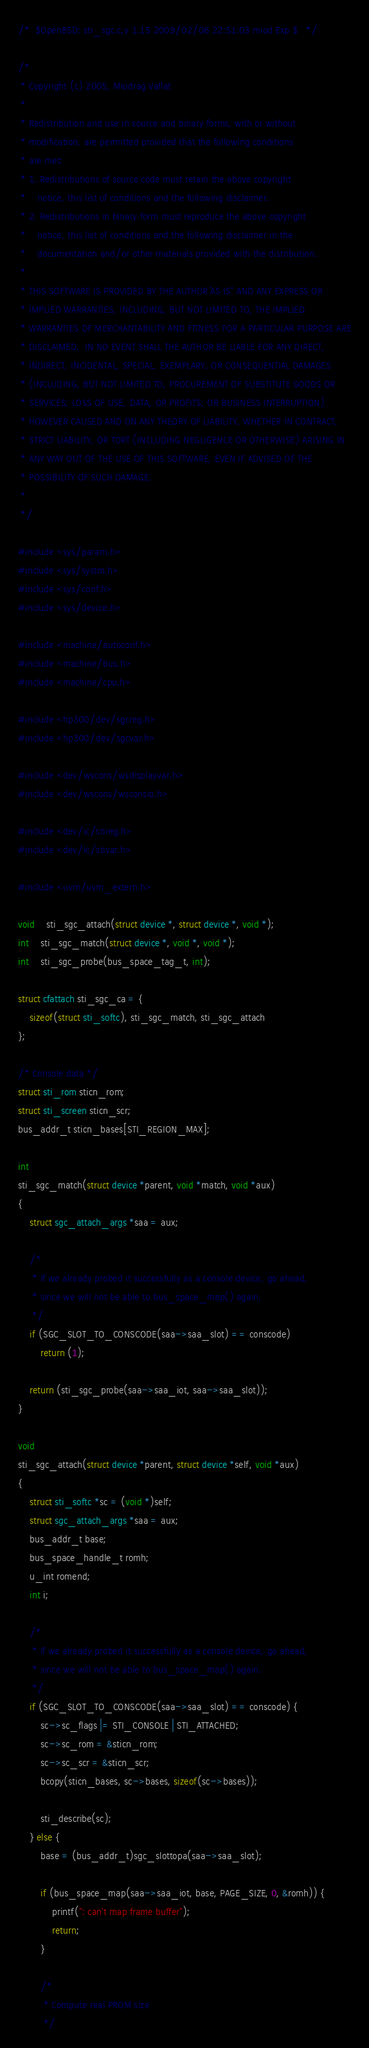<code> <loc_0><loc_0><loc_500><loc_500><_C_>/*	$OpenBSD: sti_sgc.c,v 1.15 2009/02/06 22:51:03 miod Exp $	*/

/*
 * Copyright (c) 2005, Miodrag Vallat
 *
 * Redistribution and use in source and binary forms, with or without
 * modification, are permitted provided that the following conditions
 * are met:
 * 1. Redistributions of source code must retain the above copyright
 *    notice, this list of conditions and the following disclaimer.
 * 2. Redistributions in binary form must reproduce the above copyright
 *    notice, this list of conditions and the following disclaimer in the
 *    documentation and/or other materials provided with the distribution.
 *
 * THIS SOFTWARE IS PROVIDED BY THE AUTHOR ``AS IS'' AND ANY EXPRESS OR
 * IMPLIED WARRANTIES, INCLUDING, BUT NOT LIMITED TO, THE IMPLIED
 * WARRANTIES OF MERCHANTABILITY AND FITNESS FOR A PARTICULAR PURPOSE ARE
 * DISCLAIMED.  IN NO EVENT SHALL THE AUTHOR BE LIABLE FOR ANY DIRECT,
 * INDIRECT, INCIDENTAL, SPECIAL, EXEMPLARY, OR CONSEQUENTIAL DAMAGES
 * (INCLUDING, BUT NOT LIMITED TO, PROCUREMENT OF SUBSTITUTE GOODS OR
 * SERVICES; LOSS OF USE, DATA, OR PROFITS; OR BUSINESS INTERRUPTION)
 * HOWEVER CAUSED AND ON ANY THEORY OF LIABILITY, WHETHER IN CONTRACT,
 * STRICT LIABILITY, OR TORT (INCLUDING NEGLIGENCE OR OTHERWISE) ARISING IN
 * ANY WAY OUT OF THE USE OF THIS SOFTWARE, EVEN IF ADVISED OF THE
 * POSSIBILITY OF SUCH DAMAGE.
 *
 */

#include <sys/param.h>
#include <sys/systm.h>
#include <sys/conf.h>
#include <sys/device.h>

#include <machine/autoconf.h>
#include <machine/bus.h>
#include <machine/cpu.h>

#include <hp300/dev/sgcreg.h>
#include <hp300/dev/sgcvar.h>

#include <dev/wscons/wsdisplayvar.h>
#include <dev/wscons/wsconsio.h>

#include <dev/ic/stireg.h>
#include <dev/ic/stivar.h>

#include <uvm/uvm_extern.h>

void	sti_sgc_attach(struct device *, struct device *, void *);
int	sti_sgc_match(struct device *, void *, void *);
int	sti_sgc_probe(bus_space_tag_t, int);

struct cfattach sti_sgc_ca = {
	sizeof(struct sti_softc), sti_sgc_match, sti_sgc_attach
};

/* Console data */
struct sti_rom sticn_rom;
struct sti_screen sticn_scr;
bus_addr_t sticn_bases[STI_REGION_MAX];

int
sti_sgc_match(struct device *parent, void *match, void *aux)
{
	struct sgc_attach_args *saa = aux;

	/*
	 * If we already probed it successfully as a console device, go ahead,
	 * since we will not be able to bus_space_map() again.
	 */
	if (SGC_SLOT_TO_CONSCODE(saa->saa_slot) == conscode)
		return (1);

	return (sti_sgc_probe(saa->saa_iot, saa->saa_slot));
}

void
sti_sgc_attach(struct device *parent, struct device *self, void *aux)
{
	struct sti_softc *sc = (void *)self;
	struct sgc_attach_args *saa = aux;
	bus_addr_t base;
	bus_space_handle_t romh;
	u_int romend;
	int i;

	/*
	 * If we already probed it successfully as a console device, go ahead,
	 * since we will not be able to bus_space_map() again.
	 */
	if (SGC_SLOT_TO_CONSCODE(saa->saa_slot) == conscode) {
		sc->sc_flags |= STI_CONSOLE | STI_ATTACHED;
		sc->sc_rom = &sticn_rom;
		sc->sc_scr = &sticn_scr;
		bcopy(sticn_bases, sc->bases, sizeof(sc->bases));

		sti_describe(sc);
	} else {
		base = (bus_addr_t)sgc_slottopa(saa->saa_slot);

		if (bus_space_map(saa->saa_iot, base, PAGE_SIZE, 0, &romh)) {
			printf(": can't map frame buffer");
			return;
		}

		/*
		 * Compute real PROM size
		 */</code> 